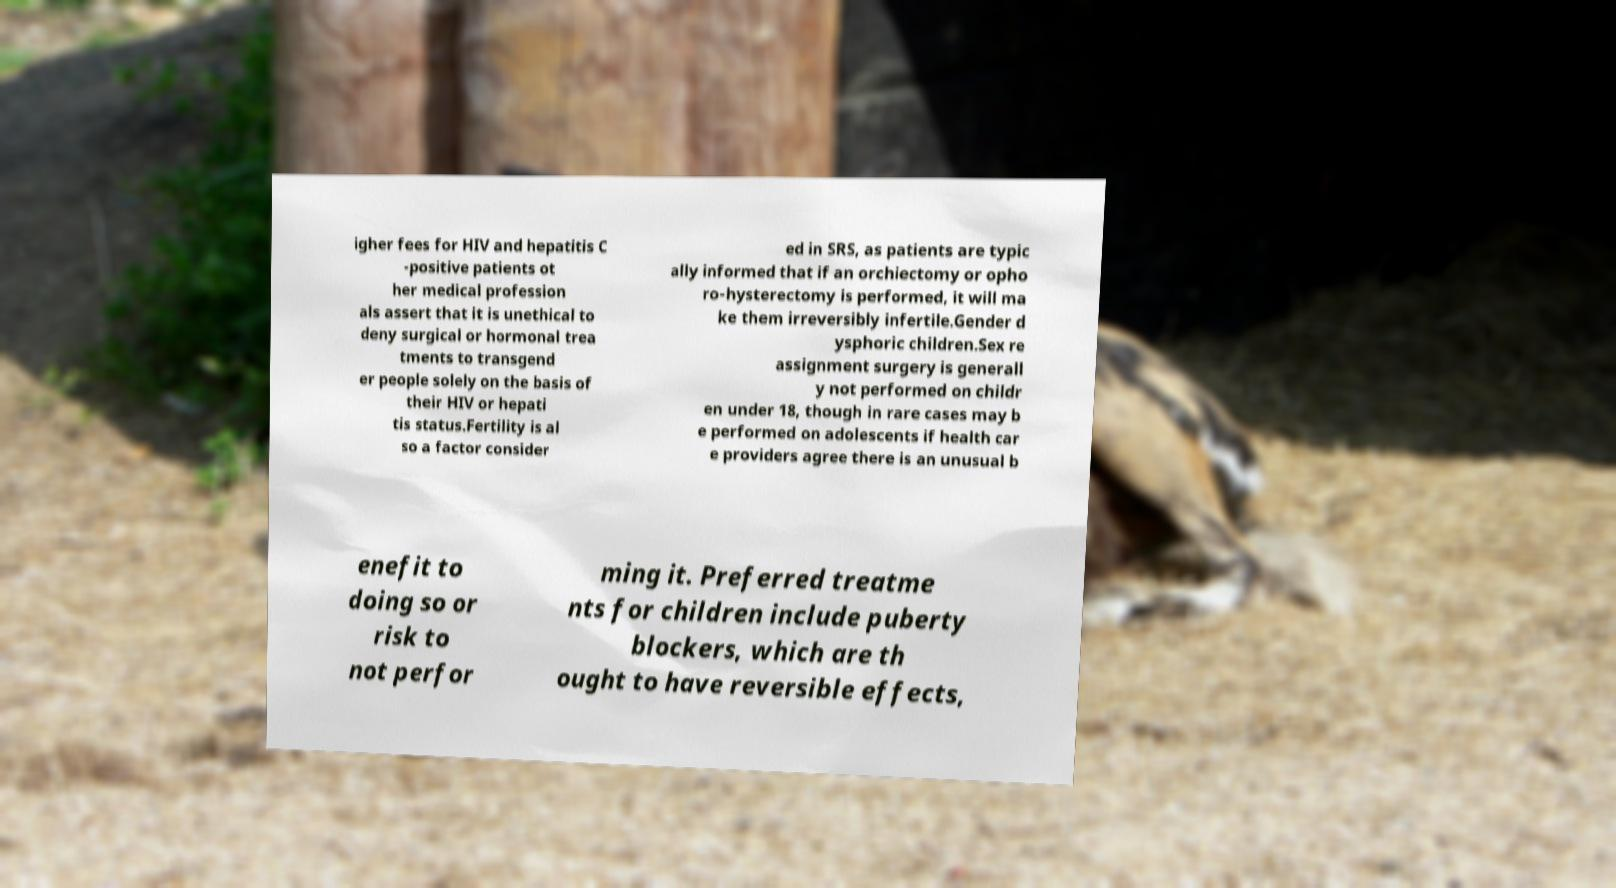What messages or text are displayed in this image? I need them in a readable, typed format. igher fees for HIV and hepatitis C -positive patients ot her medical profession als assert that it is unethical to deny surgical or hormonal trea tments to transgend er people solely on the basis of their HIV or hepati tis status.Fertility is al so a factor consider ed in SRS, as patients are typic ally informed that if an orchiectomy or opho ro-hysterectomy is performed, it will ma ke them irreversibly infertile.Gender d ysphoric children.Sex re assignment surgery is generall y not performed on childr en under 18, though in rare cases may b e performed on adolescents if health car e providers agree there is an unusual b enefit to doing so or risk to not perfor ming it. Preferred treatme nts for children include puberty blockers, which are th ought to have reversible effects, 